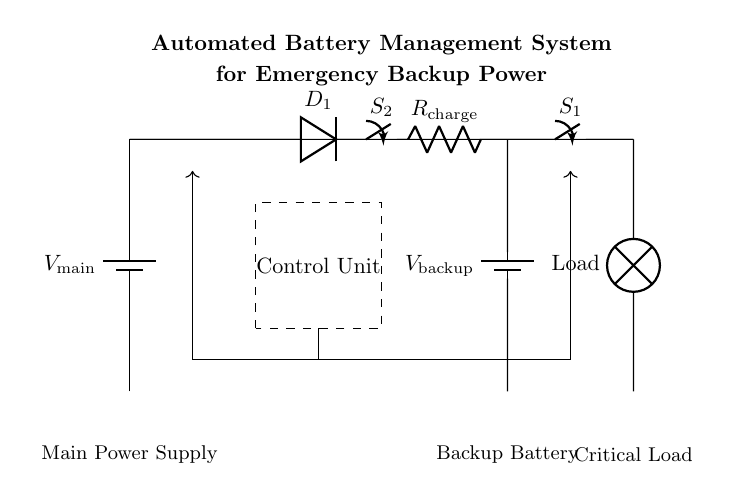What is the main power supply voltage? The circuit shows the main power supply labeled as V_main, but the actual voltage value is not specified in the diagram. We can say it represents a standard voltage supply commonly used in circuits.
Answer: V_main What component is used for charging the backup battery? In the circuit, the diode labeled D_1 allows current to flow towards the backup battery, indicating its role in the charging process. The resistor R_charge is also present, which typically regulates the charging current.
Answer: Diode (D_1) What is the purpose of the control unit in the circuit? The control unit assists in managing the operation of the circuit by providing signals to the connected components, ensuring the system functions correctly. It is represented by the dashed rectangle in the circuit.
Answer: Manage operations How many switches are present in the circuit? The circuit has two switches, labeled S_1 and S_2, which are used to control the power flow to the critical load and backup battery.
Answer: Two How does the charge flow from the main power supply during normal operation? Under normal operation, current flows from the main power supply through the switch S_2, passes through the diode D_1, and reaches the backup battery while also supplying power to the load through switch S_1.
Answer: Through S_2 to D_1 Which component helps prevent backflow of current into the main power supply? The component responsible for this function is the diode D_1, which allows current to flow only in one direction, preventing any backflow that could disrupt the power supply operation.
Answer: Diode (D_1) 